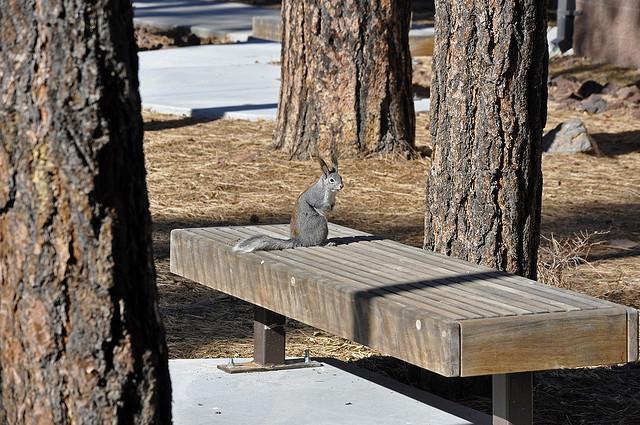How many people are in the photo?
Give a very brief answer. 0. 